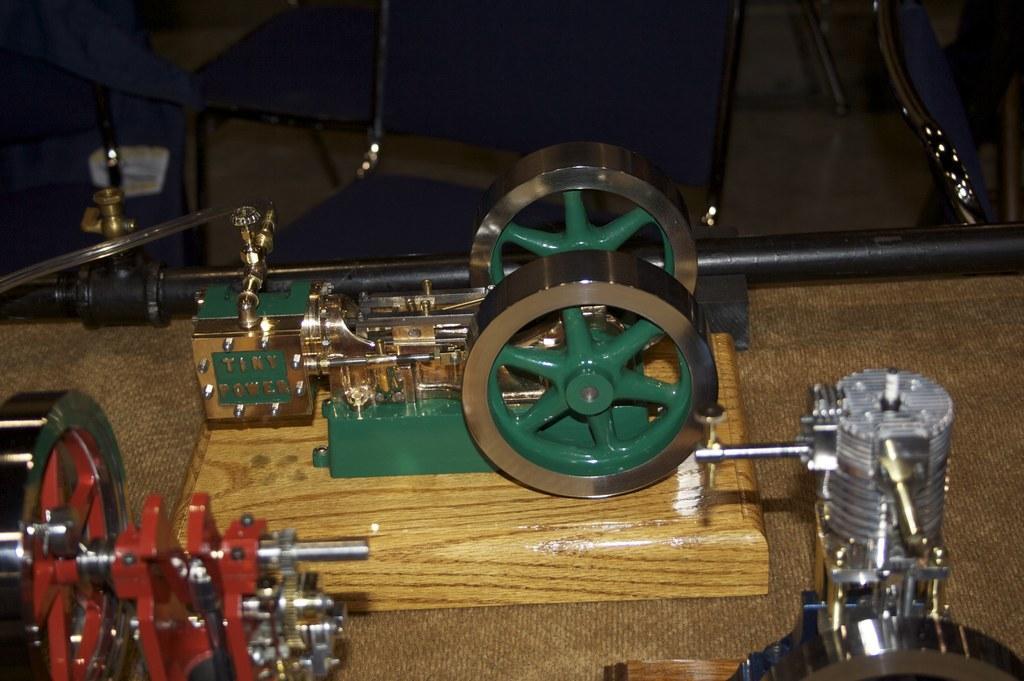Can you describe this image briefly? In this picture there are metal lathes in the image which area placed on the table and there is a bag at the top side of the image. 